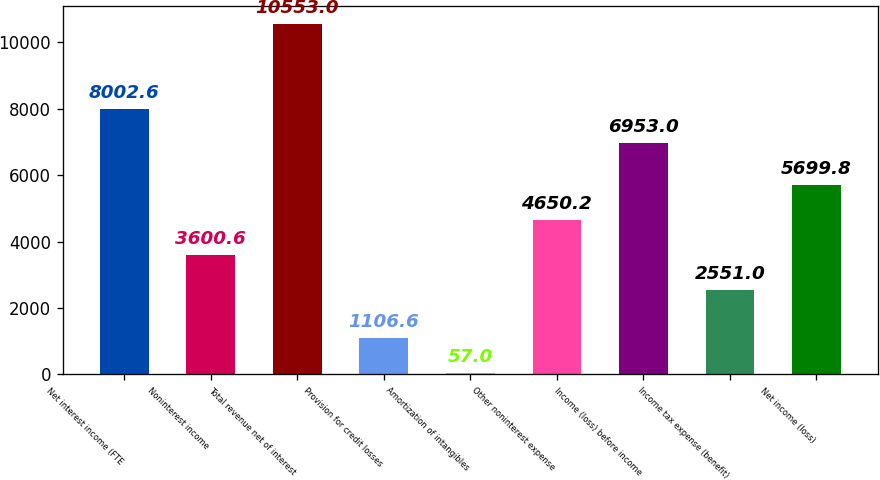<chart> <loc_0><loc_0><loc_500><loc_500><bar_chart><fcel>Net interest income (FTE<fcel>Noninterest income<fcel>Total revenue net of interest<fcel>Provision for credit losses<fcel>Amortization of intangibles<fcel>Other noninterest expense<fcel>Income (loss) before income<fcel>Income tax expense (benefit)<fcel>Net income (loss)<nl><fcel>8002.6<fcel>3600.6<fcel>10553<fcel>1106.6<fcel>57<fcel>4650.2<fcel>6953<fcel>2551<fcel>5699.8<nl></chart> 